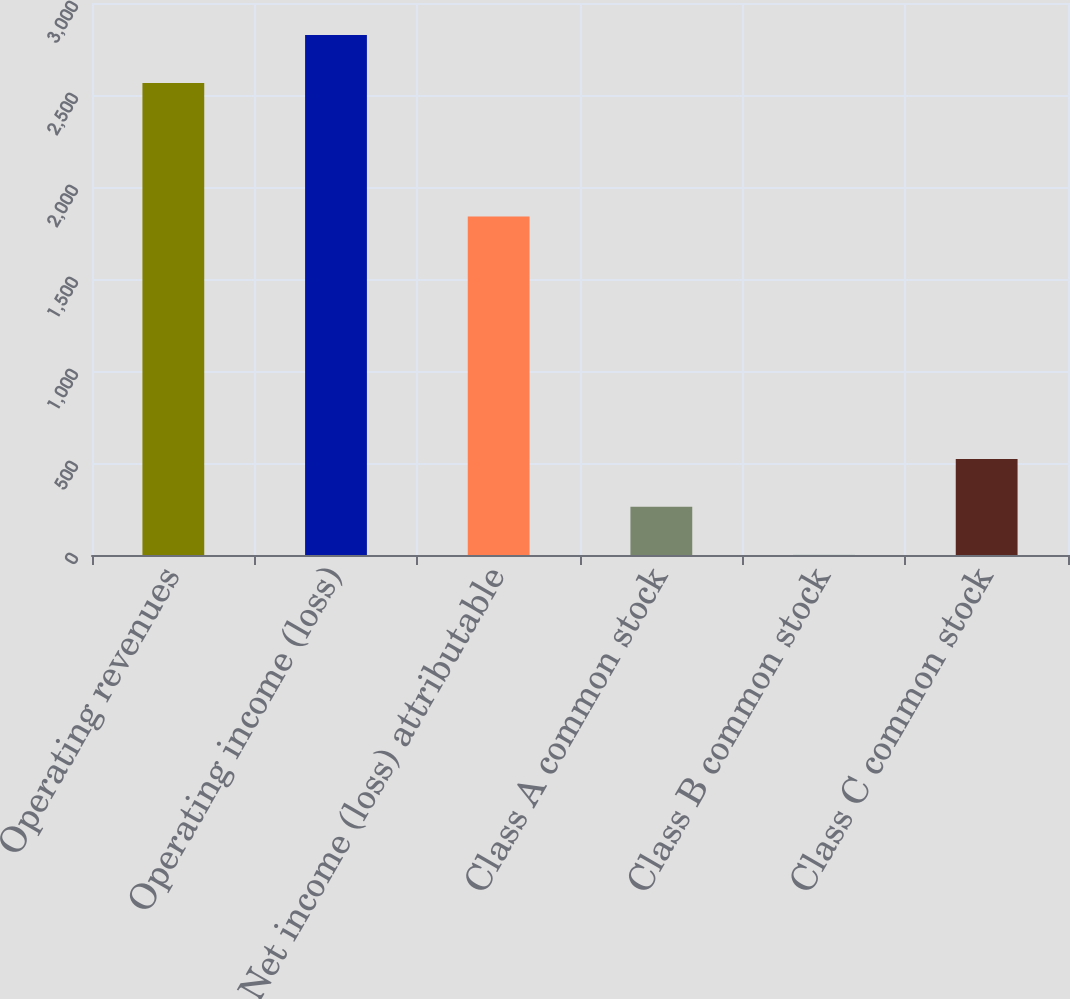<chart> <loc_0><loc_0><loc_500><loc_500><bar_chart><fcel>Operating revenues<fcel>Operating income (loss)<fcel>Net income (loss) attributable<fcel>Class A common stock<fcel>Class B common stock<fcel>Class C common stock<nl><fcel>2565<fcel>2825.58<fcel>1839<fcel>261.74<fcel>1.16<fcel>522.32<nl></chart> 